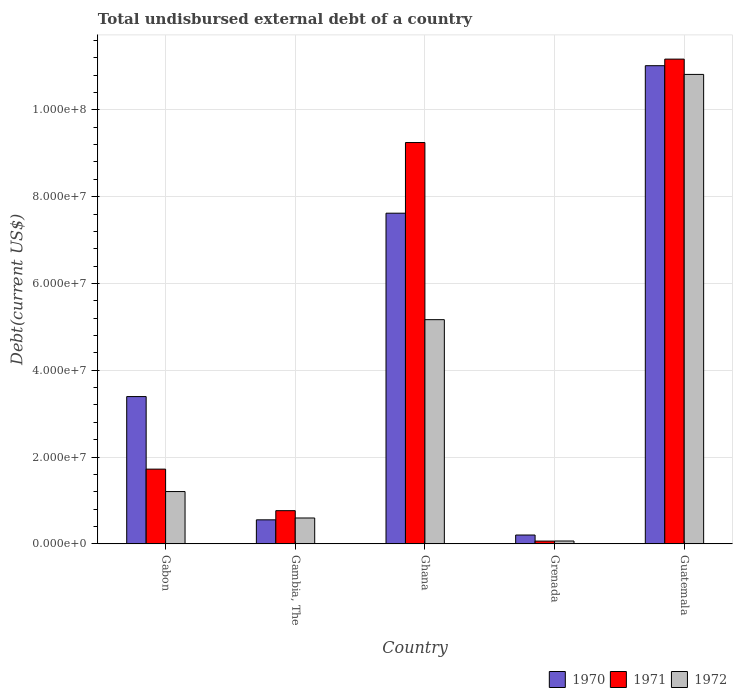How many different coloured bars are there?
Give a very brief answer. 3. Are the number of bars on each tick of the X-axis equal?
Ensure brevity in your answer.  Yes. How many bars are there on the 4th tick from the right?
Your response must be concise. 3. What is the label of the 5th group of bars from the left?
Make the answer very short. Guatemala. In how many cases, is the number of bars for a given country not equal to the number of legend labels?
Make the answer very short. 0. What is the total undisbursed external debt in 1970 in Gabon?
Your answer should be compact. 3.39e+07. Across all countries, what is the maximum total undisbursed external debt in 1971?
Offer a very short reply. 1.12e+08. Across all countries, what is the minimum total undisbursed external debt in 1971?
Make the answer very short. 6.39e+05. In which country was the total undisbursed external debt in 1971 maximum?
Provide a short and direct response. Guatemala. In which country was the total undisbursed external debt in 1971 minimum?
Provide a short and direct response. Grenada. What is the total total undisbursed external debt in 1971 in the graph?
Offer a terse response. 2.30e+08. What is the difference between the total undisbursed external debt in 1971 in Gabon and that in Guatemala?
Offer a very short reply. -9.45e+07. What is the difference between the total undisbursed external debt in 1972 in Gabon and the total undisbursed external debt in 1971 in Guatemala?
Your answer should be very brief. -9.96e+07. What is the average total undisbursed external debt in 1972 per country?
Offer a terse response. 3.57e+07. What is the difference between the total undisbursed external debt of/in 1971 and total undisbursed external debt of/in 1972 in Grenada?
Offer a terse response. -1.80e+04. What is the ratio of the total undisbursed external debt in 1972 in Ghana to that in Grenada?
Ensure brevity in your answer.  78.63. What is the difference between the highest and the second highest total undisbursed external debt in 1972?
Offer a terse response. 5.65e+07. What is the difference between the highest and the lowest total undisbursed external debt in 1972?
Ensure brevity in your answer.  1.08e+08. In how many countries, is the total undisbursed external debt in 1971 greater than the average total undisbursed external debt in 1971 taken over all countries?
Offer a terse response. 2. Is the sum of the total undisbursed external debt in 1970 in Gambia, The and Ghana greater than the maximum total undisbursed external debt in 1971 across all countries?
Provide a short and direct response. No. What does the 3rd bar from the left in Gambia, The represents?
Give a very brief answer. 1972. What does the 3rd bar from the right in Ghana represents?
Offer a terse response. 1970. How many bars are there?
Provide a succinct answer. 15. How many countries are there in the graph?
Your answer should be very brief. 5. Are the values on the major ticks of Y-axis written in scientific E-notation?
Give a very brief answer. Yes. Does the graph contain grids?
Provide a succinct answer. Yes. Where does the legend appear in the graph?
Keep it short and to the point. Bottom right. What is the title of the graph?
Your answer should be compact. Total undisbursed external debt of a country. What is the label or title of the X-axis?
Offer a terse response. Country. What is the label or title of the Y-axis?
Ensure brevity in your answer.  Debt(current US$). What is the Debt(current US$) of 1970 in Gabon?
Your answer should be very brief. 3.39e+07. What is the Debt(current US$) of 1971 in Gabon?
Provide a succinct answer. 1.72e+07. What is the Debt(current US$) in 1972 in Gabon?
Your response must be concise. 1.21e+07. What is the Debt(current US$) of 1970 in Gambia, The?
Provide a succinct answer. 5.54e+06. What is the Debt(current US$) in 1971 in Gambia, The?
Your answer should be very brief. 7.65e+06. What is the Debt(current US$) of 1972 in Gambia, The?
Provide a succinct answer. 5.96e+06. What is the Debt(current US$) in 1970 in Ghana?
Give a very brief answer. 7.62e+07. What is the Debt(current US$) of 1971 in Ghana?
Make the answer very short. 9.25e+07. What is the Debt(current US$) in 1972 in Ghana?
Offer a very short reply. 5.17e+07. What is the Debt(current US$) in 1970 in Grenada?
Keep it short and to the point. 2.04e+06. What is the Debt(current US$) of 1971 in Grenada?
Provide a short and direct response. 6.39e+05. What is the Debt(current US$) of 1972 in Grenada?
Make the answer very short. 6.57e+05. What is the Debt(current US$) in 1970 in Guatemala?
Provide a succinct answer. 1.10e+08. What is the Debt(current US$) of 1971 in Guatemala?
Offer a very short reply. 1.12e+08. What is the Debt(current US$) in 1972 in Guatemala?
Your answer should be very brief. 1.08e+08. Across all countries, what is the maximum Debt(current US$) of 1970?
Keep it short and to the point. 1.10e+08. Across all countries, what is the maximum Debt(current US$) of 1971?
Offer a terse response. 1.12e+08. Across all countries, what is the maximum Debt(current US$) in 1972?
Offer a terse response. 1.08e+08. Across all countries, what is the minimum Debt(current US$) in 1970?
Your answer should be very brief. 2.04e+06. Across all countries, what is the minimum Debt(current US$) in 1971?
Give a very brief answer. 6.39e+05. Across all countries, what is the minimum Debt(current US$) of 1972?
Give a very brief answer. 6.57e+05. What is the total Debt(current US$) in 1970 in the graph?
Your response must be concise. 2.28e+08. What is the total Debt(current US$) in 1971 in the graph?
Your answer should be compact. 2.30e+08. What is the total Debt(current US$) in 1972 in the graph?
Your answer should be compact. 1.78e+08. What is the difference between the Debt(current US$) in 1970 in Gabon and that in Gambia, The?
Offer a very short reply. 2.84e+07. What is the difference between the Debt(current US$) in 1971 in Gabon and that in Gambia, The?
Keep it short and to the point. 9.57e+06. What is the difference between the Debt(current US$) of 1972 in Gabon and that in Gambia, The?
Provide a short and direct response. 6.09e+06. What is the difference between the Debt(current US$) of 1970 in Gabon and that in Ghana?
Provide a succinct answer. -4.23e+07. What is the difference between the Debt(current US$) in 1971 in Gabon and that in Ghana?
Keep it short and to the point. -7.53e+07. What is the difference between the Debt(current US$) of 1972 in Gabon and that in Ghana?
Give a very brief answer. -3.96e+07. What is the difference between the Debt(current US$) of 1970 in Gabon and that in Grenada?
Your answer should be very brief. 3.19e+07. What is the difference between the Debt(current US$) in 1971 in Gabon and that in Grenada?
Keep it short and to the point. 1.66e+07. What is the difference between the Debt(current US$) of 1972 in Gabon and that in Grenada?
Ensure brevity in your answer.  1.14e+07. What is the difference between the Debt(current US$) of 1970 in Gabon and that in Guatemala?
Provide a succinct answer. -7.62e+07. What is the difference between the Debt(current US$) in 1971 in Gabon and that in Guatemala?
Keep it short and to the point. -9.45e+07. What is the difference between the Debt(current US$) in 1972 in Gabon and that in Guatemala?
Give a very brief answer. -9.61e+07. What is the difference between the Debt(current US$) in 1970 in Gambia, The and that in Ghana?
Keep it short and to the point. -7.07e+07. What is the difference between the Debt(current US$) in 1971 in Gambia, The and that in Ghana?
Your response must be concise. -8.48e+07. What is the difference between the Debt(current US$) in 1972 in Gambia, The and that in Ghana?
Provide a short and direct response. -4.57e+07. What is the difference between the Debt(current US$) of 1970 in Gambia, The and that in Grenada?
Offer a terse response. 3.50e+06. What is the difference between the Debt(current US$) in 1971 in Gambia, The and that in Grenada?
Provide a short and direct response. 7.01e+06. What is the difference between the Debt(current US$) in 1972 in Gambia, The and that in Grenada?
Give a very brief answer. 5.30e+06. What is the difference between the Debt(current US$) in 1970 in Gambia, The and that in Guatemala?
Your answer should be very brief. -1.05e+08. What is the difference between the Debt(current US$) in 1971 in Gambia, The and that in Guatemala?
Provide a short and direct response. -1.04e+08. What is the difference between the Debt(current US$) of 1972 in Gambia, The and that in Guatemala?
Offer a terse response. -1.02e+08. What is the difference between the Debt(current US$) of 1970 in Ghana and that in Grenada?
Ensure brevity in your answer.  7.42e+07. What is the difference between the Debt(current US$) in 1971 in Ghana and that in Grenada?
Ensure brevity in your answer.  9.18e+07. What is the difference between the Debt(current US$) of 1972 in Ghana and that in Grenada?
Provide a short and direct response. 5.10e+07. What is the difference between the Debt(current US$) of 1970 in Ghana and that in Guatemala?
Make the answer very short. -3.40e+07. What is the difference between the Debt(current US$) of 1971 in Ghana and that in Guatemala?
Ensure brevity in your answer.  -1.92e+07. What is the difference between the Debt(current US$) in 1972 in Ghana and that in Guatemala?
Your answer should be very brief. -5.65e+07. What is the difference between the Debt(current US$) of 1970 in Grenada and that in Guatemala?
Offer a terse response. -1.08e+08. What is the difference between the Debt(current US$) of 1971 in Grenada and that in Guatemala?
Offer a very short reply. -1.11e+08. What is the difference between the Debt(current US$) of 1972 in Grenada and that in Guatemala?
Your response must be concise. -1.08e+08. What is the difference between the Debt(current US$) in 1970 in Gabon and the Debt(current US$) in 1971 in Gambia, The?
Ensure brevity in your answer.  2.63e+07. What is the difference between the Debt(current US$) of 1970 in Gabon and the Debt(current US$) of 1972 in Gambia, The?
Provide a succinct answer. 2.80e+07. What is the difference between the Debt(current US$) of 1971 in Gabon and the Debt(current US$) of 1972 in Gambia, The?
Your answer should be very brief. 1.13e+07. What is the difference between the Debt(current US$) of 1970 in Gabon and the Debt(current US$) of 1971 in Ghana?
Provide a succinct answer. -5.85e+07. What is the difference between the Debt(current US$) in 1970 in Gabon and the Debt(current US$) in 1972 in Ghana?
Your response must be concise. -1.77e+07. What is the difference between the Debt(current US$) of 1971 in Gabon and the Debt(current US$) of 1972 in Ghana?
Provide a short and direct response. -3.44e+07. What is the difference between the Debt(current US$) in 1970 in Gabon and the Debt(current US$) in 1971 in Grenada?
Provide a succinct answer. 3.33e+07. What is the difference between the Debt(current US$) of 1970 in Gabon and the Debt(current US$) of 1972 in Grenada?
Your response must be concise. 3.33e+07. What is the difference between the Debt(current US$) of 1971 in Gabon and the Debt(current US$) of 1972 in Grenada?
Provide a succinct answer. 1.66e+07. What is the difference between the Debt(current US$) of 1970 in Gabon and the Debt(current US$) of 1971 in Guatemala?
Your answer should be very brief. -7.78e+07. What is the difference between the Debt(current US$) in 1970 in Gabon and the Debt(current US$) in 1972 in Guatemala?
Your answer should be compact. -7.42e+07. What is the difference between the Debt(current US$) in 1971 in Gabon and the Debt(current US$) in 1972 in Guatemala?
Give a very brief answer. -9.10e+07. What is the difference between the Debt(current US$) in 1970 in Gambia, The and the Debt(current US$) in 1971 in Ghana?
Give a very brief answer. -8.69e+07. What is the difference between the Debt(current US$) of 1970 in Gambia, The and the Debt(current US$) of 1972 in Ghana?
Give a very brief answer. -4.61e+07. What is the difference between the Debt(current US$) in 1971 in Gambia, The and the Debt(current US$) in 1972 in Ghana?
Offer a very short reply. -4.40e+07. What is the difference between the Debt(current US$) of 1970 in Gambia, The and the Debt(current US$) of 1971 in Grenada?
Provide a short and direct response. 4.90e+06. What is the difference between the Debt(current US$) of 1970 in Gambia, The and the Debt(current US$) of 1972 in Grenada?
Ensure brevity in your answer.  4.88e+06. What is the difference between the Debt(current US$) in 1971 in Gambia, The and the Debt(current US$) in 1972 in Grenada?
Provide a succinct answer. 6.99e+06. What is the difference between the Debt(current US$) of 1970 in Gambia, The and the Debt(current US$) of 1971 in Guatemala?
Provide a succinct answer. -1.06e+08. What is the difference between the Debt(current US$) of 1970 in Gambia, The and the Debt(current US$) of 1972 in Guatemala?
Your answer should be compact. -1.03e+08. What is the difference between the Debt(current US$) of 1971 in Gambia, The and the Debt(current US$) of 1972 in Guatemala?
Give a very brief answer. -1.01e+08. What is the difference between the Debt(current US$) of 1970 in Ghana and the Debt(current US$) of 1971 in Grenada?
Your answer should be compact. 7.56e+07. What is the difference between the Debt(current US$) in 1970 in Ghana and the Debt(current US$) in 1972 in Grenada?
Your answer should be compact. 7.55e+07. What is the difference between the Debt(current US$) of 1971 in Ghana and the Debt(current US$) of 1972 in Grenada?
Provide a short and direct response. 9.18e+07. What is the difference between the Debt(current US$) of 1970 in Ghana and the Debt(current US$) of 1971 in Guatemala?
Offer a terse response. -3.55e+07. What is the difference between the Debt(current US$) in 1970 in Ghana and the Debt(current US$) in 1972 in Guatemala?
Provide a succinct answer. -3.20e+07. What is the difference between the Debt(current US$) of 1971 in Ghana and the Debt(current US$) of 1972 in Guatemala?
Provide a succinct answer. -1.57e+07. What is the difference between the Debt(current US$) of 1970 in Grenada and the Debt(current US$) of 1971 in Guatemala?
Provide a short and direct response. -1.10e+08. What is the difference between the Debt(current US$) of 1970 in Grenada and the Debt(current US$) of 1972 in Guatemala?
Your answer should be very brief. -1.06e+08. What is the difference between the Debt(current US$) in 1971 in Grenada and the Debt(current US$) in 1972 in Guatemala?
Provide a succinct answer. -1.08e+08. What is the average Debt(current US$) of 1970 per country?
Your response must be concise. 4.56e+07. What is the average Debt(current US$) in 1971 per country?
Offer a very short reply. 4.59e+07. What is the average Debt(current US$) in 1972 per country?
Keep it short and to the point. 3.57e+07. What is the difference between the Debt(current US$) of 1970 and Debt(current US$) of 1971 in Gabon?
Offer a terse response. 1.67e+07. What is the difference between the Debt(current US$) in 1970 and Debt(current US$) in 1972 in Gabon?
Offer a very short reply. 2.19e+07. What is the difference between the Debt(current US$) in 1971 and Debt(current US$) in 1972 in Gabon?
Provide a succinct answer. 5.17e+06. What is the difference between the Debt(current US$) in 1970 and Debt(current US$) in 1971 in Gambia, The?
Ensure brevity in your answer.  -2.11e+06. What is the difference between the Debt(current US$) in 1970 and Debt(current US$) in 1972 in Gambia, The?
Ensure brevity in your answer.  -4.26e+05. What is the difference between the Debt(current US$) in 1971 and Debt(current US$) in 1972 in Gambia, The?
Offer a terse response. 1.69e+06. What is the difference between the Debt(current US$) in 1970 and Debt(current US$) in 1971 in Ghana?
Your answer should be compact. -1.63e+07. What is the difference between the Debt(current US$) of 1970 and Debt(current US$) of 1972 in Ghana?
Give a very brief answer. 2.45e+07. What is the difference between the Debt(current US$) of 1971 and Debt(current US$) of 1972 in Ghana?
Provide a short and direct response. 4.08e+07. What is the difference between the Debt(current US$) in 1970 and Debt(current US$) in 1971 in Grenada?
Your answer should be very brief. 1.40e+06. What is the difference between the Debt(current US$) of 1970 and Debt(current US$) of 1972 in Grenada?
Keep it short and to the point. 1.38e+06. What is the difference between the Debt(current US$) of 1971 and Debt(current US$) of 1972 in Grenada?
Your answer should be very brief. -1.80e+04. What is the difference between the Debt(current US$) of 1970 and Debt(current US$) of 1971 in Guatemala?
Your answer should be very brief. -1.52e+06. What is the difference between the Debt(current US$) in 1970 and Debt(current US$) in 1972 in Guatemala?
Offer a very short reply. 2.01e+06. What is the difference between the Debt(current US$) of 1971 and Debt(current US$) of 1972 in Guatemala?
Ensure brevity in your answer.  3.52e+06. What is the ratio of the Debt(current US$) of 1970 in Gabon to that in Gambia, The?
Your answer should be compact. 6.13. What is the ratio of the Debt(current US$) of 1971 in Gabon to that in Gambia, The?
Your response must be concise. 2.25. What is the ratio of the Debt(current US$) of 1972 in Gabon to that in Gambia, The?
Your response must be concise. 2.02. What is the ratio of the Debt(current US$) in 1970 in Gabon to that in Ghana?
Keep it short and to the point. 0.45. What is the ratio of the Debt(current US$) in 1971 in Gabon to that in Ghana?
Your response must be concise. 0.19. What is the ratio of the Debt(current US$) of 1972 in Gabon to that in Ghana?
Give a very brief answer. 0.23. What is the ratio of the Debt(current US$) of 1970 in Gabon to that in Grenada?
Provide a short and direct response. 16.66. What is the ratio of the Debt(current US$) of 1971 in Gabon to that in Grenada?
Offer a terse response. 26.95. What is the ratio of the Debt(current US$) of 1972 in Gabon to that in Grenada?
Provide a short and direct response. 18.34. What is the ratio of the Debt(current US$) in 1970 in Gabon to that in Guatemala?
Offer a very short reply. 0.31. What is the ratio of the Debt(current US$) in 1971 in Gabon to that in Guatemala?
Make the answer very short. 0.15. What is the ratio of the Debt(current US$) of 1972 in Gabon to that in Guatemala?
Your answer should be very brief. 0.11. What is the ratio of the Debt(current US$) in 1970 in Gambia, The to that in Ghana?
Your response must be concise. 0.07. What is the ratio of the Debt(current US$) of 1971 in Gambia, The to that in Ghana?
Your answer should be compact. 0.08. What is the ratio of the Debt(current US$) in 1972 in Gambia, The to that in Ghana?
Offer a terse response. 0.12. What is the ratio of the Debt(current US$) of 1970 in Gambia, The to that in Grenada?
Provide a short and direct response. 2.72. What is the ratio of the Debt(current US$) in 1971 in Gambia, The to that in Grenada?
Provide a short and direct response. 11.97. What is the ratio of the Debt(current US$) of 1972 in Gambia, The to that in Grenada?
Offer a very short reply. 9.07. What is the ratio of the Debt(current US$) of 1970 in Gambia, The to that in Guatemala?
Keep it short and to the point. 0.05. What is the ratio of the Debt(current US$) of 1971 in Gambia, The to that in Guatemala?
Keep it short and to the point. 0.07. What is the ratio of the Debt(current US$) in 1972 in Gambia, The to that in Guatemala?
Provide a short and direct response. 0.06. What is the ratio of the Debt(current US$) in 1970 in Ghana to that in Grenada?
Your answer should be very brief. 37.4. What is the ratio of the Debt(current US$) of 1971 in Ghana to that in Grenada?
Keep it short and to the point. 144.71. What is the ratio of the Debt(current US$) in 1972 in Ghana to that in Grenada?
Your answer should be compact. 78.63. What is the ratio of the Debt(current US$) in 1970 in Ghana to that in Guatemala?
Make the answer very short. 0.69. What is the ratio of the Debt(current US$) of 1971 in Ghana to that in Guatemala?
Offer a terse response. 0.83. What is the ratio of the Debt(current US$) in 1972 in Ghana to that in Guatemala?
Provide a succinct answer. 0.48. What is the ratio of the Debt(current US$) in 1970 in Grenada to that in Guatemala?
Offer a very short reply. 0.02. What is the ratio of the Debt(current US$) of 1971 in Grenada to that in Guatemala?
Your answer should be very brief. 0.01. What is the ratio of the Debt(current US$) of 1972 in Grenada to that in Guatemala?
Ensure brevity in your answer.  0.01. What is the difference between the highest and the second highest Debt(current US$) in 1970?
Offer a very short reply. 3.40e+07. What is the difference between the highest and the second highest Debt(current US$) of 1971?
Keep it short and to the point. 1.92e+07. What is the difference between the highest and the second highest Debt(current US$) in 1972?
Give a very brief answer. 5.65e+07. What is the difference between the highest and the lowest Debt(current US$) of 1970?
Your answer should be very brief. 1.08e+08. What is the difference between the highest and the lowest Debt(current US$) of 1971?
Ensure brevity in your answer.  1.11e+08. What is the difference between the highest and the lowest Debt(current US$) of 1972?
Provide a short and direct response. 1.08e+08. 